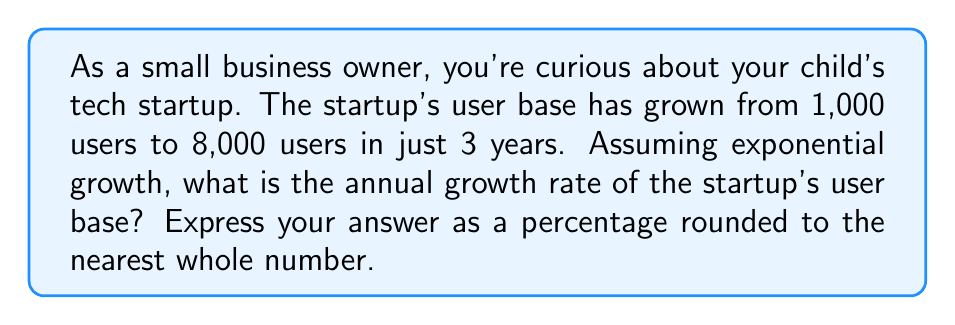Can you solve this math problem? Let's approach this step-by-step using an exponential growth model:

1) The exponential growth formula is:
   $A = P(1 + r)^t$
   Where:
   $A$ = Final amount
   $P$ = Initial amount
   $r$ = Annual growth rate (in decimal form)
   $t$ = Time in years

2) We know:
   $P = 1,000$ (initial users)
   $A = 8,000$ (final users after 3 years)
   $t = 3$ years

3) Let's plug these into our formula:
   $8,000 = 1,000(1 + r)^3$

4) Divide both sides by 1,000:
   $8 = (1 + r)^3$

5) Take the cube root of both sides:
   $\sqrt[3]{8} = 1 + r$

6) Simplify:
   $2 = 1 + r$

7) Subtract 1 from both sides:
   $1 = r$

8) Convert to a percentage:
   $r = 1 * 100\% = 100\%$

Therefore, the annual growth rate is 100%.
Answer: 100% 